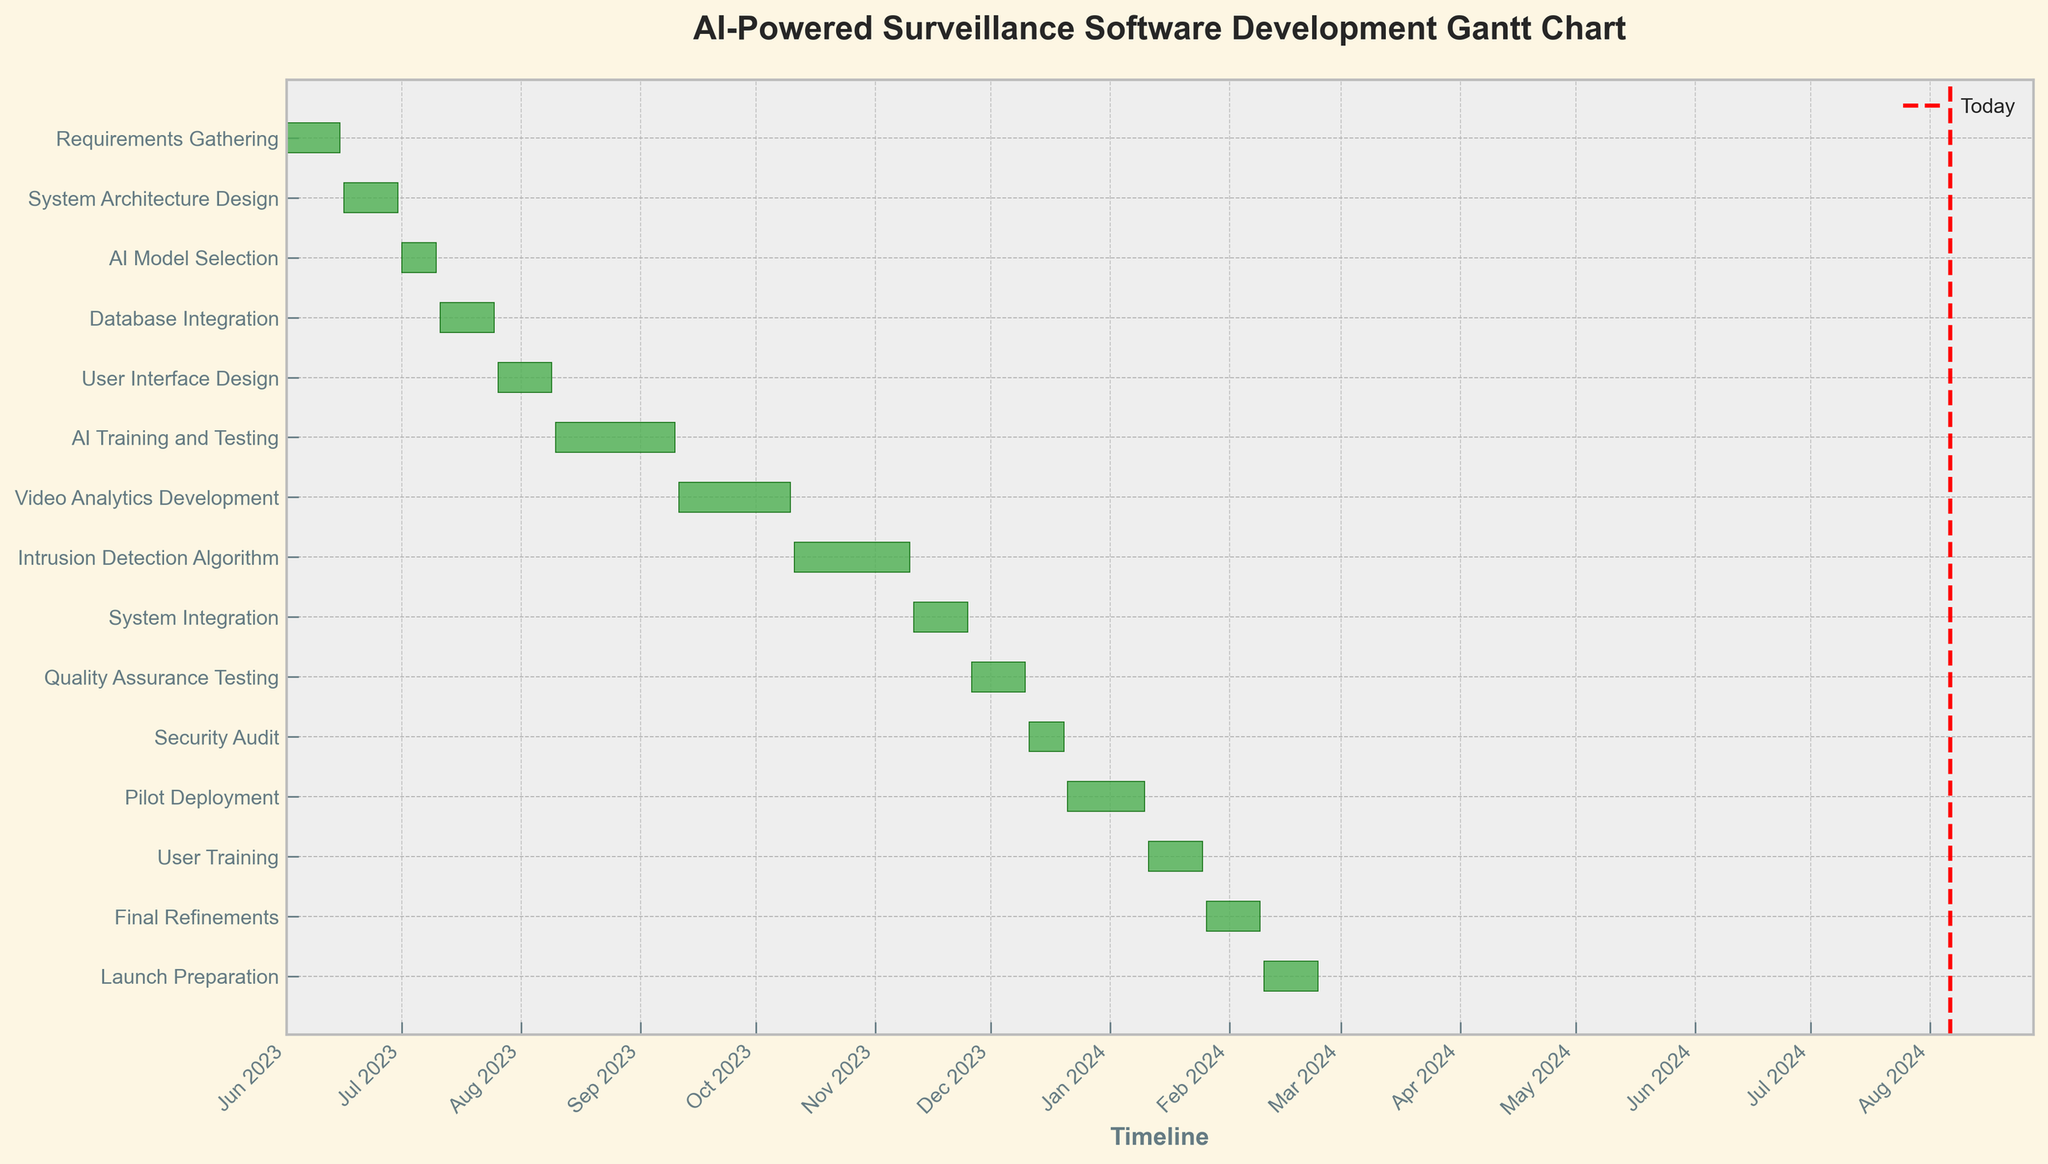What is the title of the Gantt chart? The title is displayed at the top of the figure. It typically provides a clear and concise description of the chart's content.
Answer: AI-Powered Surveillance Software Development Gantt Chart Which task has the longest duration? The duration of each task is shown as the length of the horizontal bar. The longest bar represents the task with the longest duration.
Answer: AI Training and Testing How many tasks are scheduled to start in August 2023? Identify the bars whose start dates fall within August 2023 by looking at the timeline on the x-axis.
Answer: 1 What's the total duration of the `Requirements Gathering` and `System Architecture Design` tasks? Add the durations of `Requirements Gathering` and `System Architecture Design` as shown in the data. `Requirements Gathering` is 15 days, and `System Architecture Design` is 15 days. Sum them up: 15 + 15 = 30 days.
Answer: 30 days Which two tasks are scheduled to end in November 2023? Check the x-axis timeline in November 2023, and find the end dates of the tasks that fall within this month.
Answer: Intrusion Detection Algorithm and System Integration When does the `User Training` task start and end? Find the `User Training` task on the y-axis, then look at its corresponding start and end dates on the timeline. The task starts on 2024-01-11 and ends on 2024-01-25.
Answer: 2024-01-11 to 2024-01-25 Is the `System Integration` task overlapping with `Quality Assurance Testing`? Look at the bars for `System Integration` and `Quality Assurance Testing` on the timeline. If their date ranges overlap, then they are overlapping tasks.
Answer: No How long is the gap between the end of `AI Training and Testing` and the start of `Video Analytics Development`? Determine the end date of `AI Training and Testing` (2023-09-10) and the start date of `Video Analytics Development` (2023-09-11). The gap is the difference between these dates.
Answer: 1 day What is the total number of tasks in this Gantt chart? Count the number of bars (or tasks) listed along the y-axis.
Answer: 15 Which task finishes closest to the current date? Find the `Today` line in red on the chart and look for the task whose end date is nearest to this line.
Answer: Pilot Deployment 